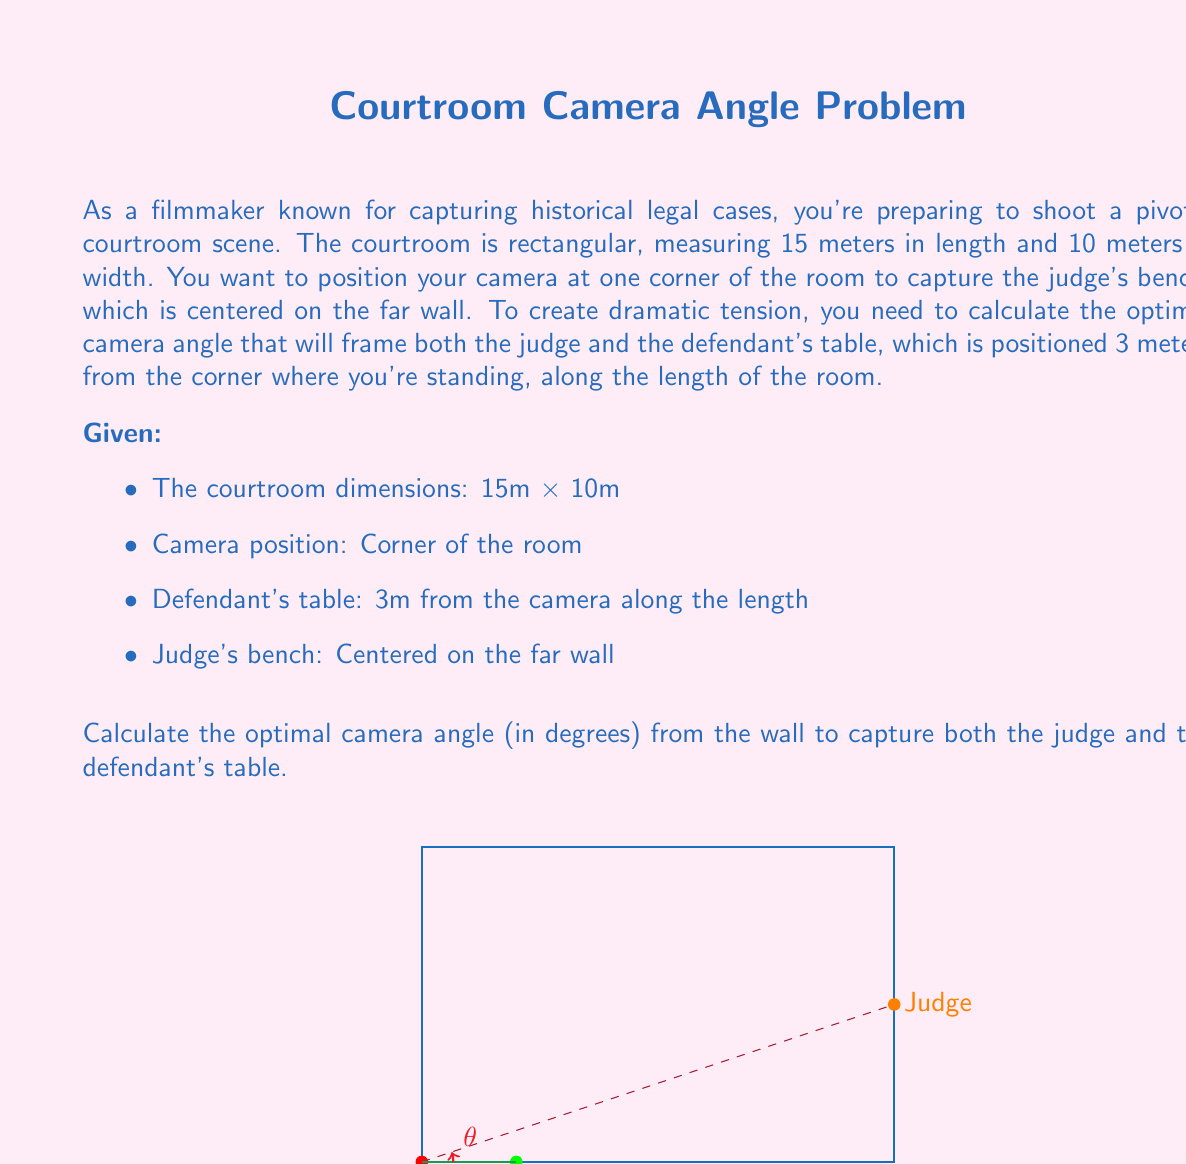Teach me how to tackle this problem. Let's approach this step-by-step using trigonometric functions:

1) First, we need to find the angle between the camera-to-defendant line and the camera-to-judge line.

2) For the camera-to-defendant line:
   - This is simply along the length of the room, 3 meters from the corner.
   - We don't need to calculate an angle for this, as it's our reference line.

3) For the camera-to-judge line:
   - We need to use the tangent function to find this angle.
   - The opposite side is half the width of the room (5 meters), as the judge is centered.
   - The adjacent side is the full length of the room (15 meters).

4) Let's call our desired angle θ. We can set up the equation:

   $$\tan(θ) = \frac{\text{opposite}}{\text{adjacent}} = \frac{5}{15}$$

5) To solve for θ, we use the inverse tangent (arctan) function:

   $$θ = \arctan(\frac{5}{15})$$

6) Simplifying the fraction inside the arctan:

   $$θ = \arctan(\frac{1}{3})$$

7) Using a calculator or mathematical software to evaluate this:

   $$θ ≈ 18.43°$$

This angle represents the optimal camera angle from the wall to capture both the judge and the defendant's table, creating the desired dramatic tension in the scene.
Answer: $18.43°$ 